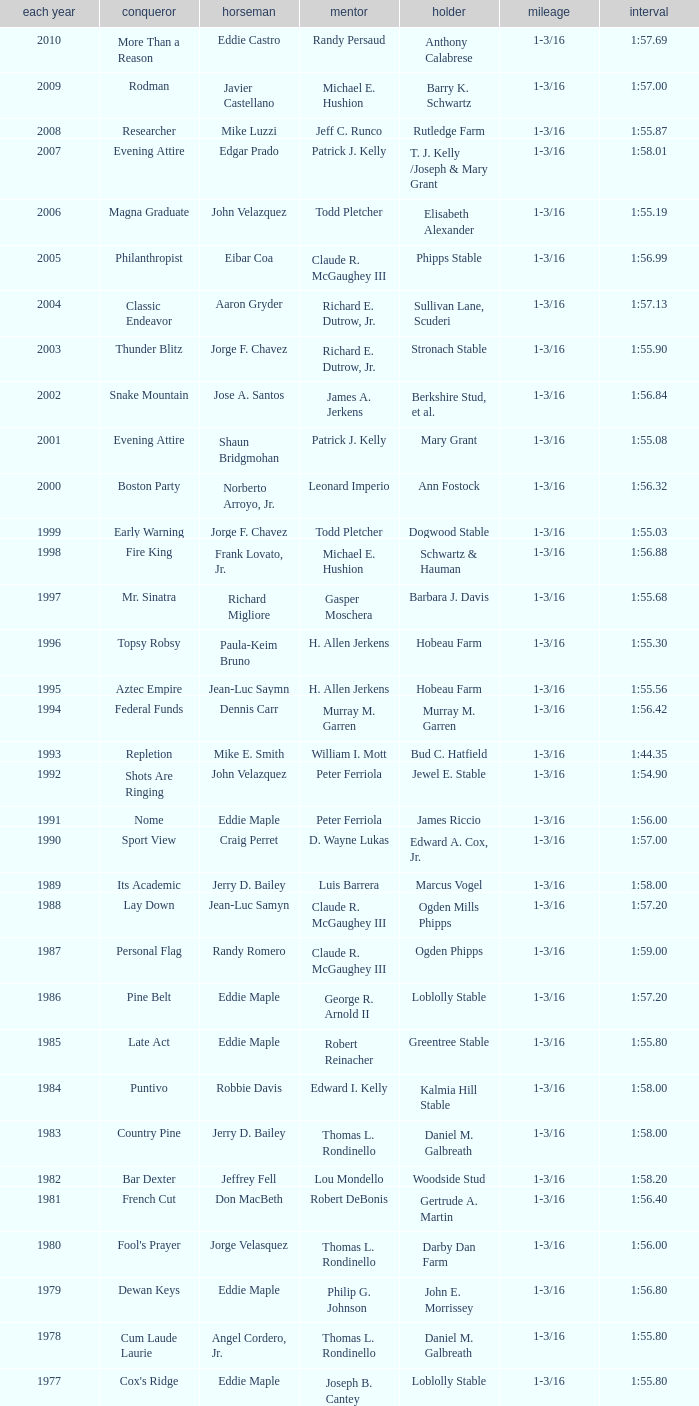What was the winning time for the winning horse, Kentucky ii? 1:38.80. 